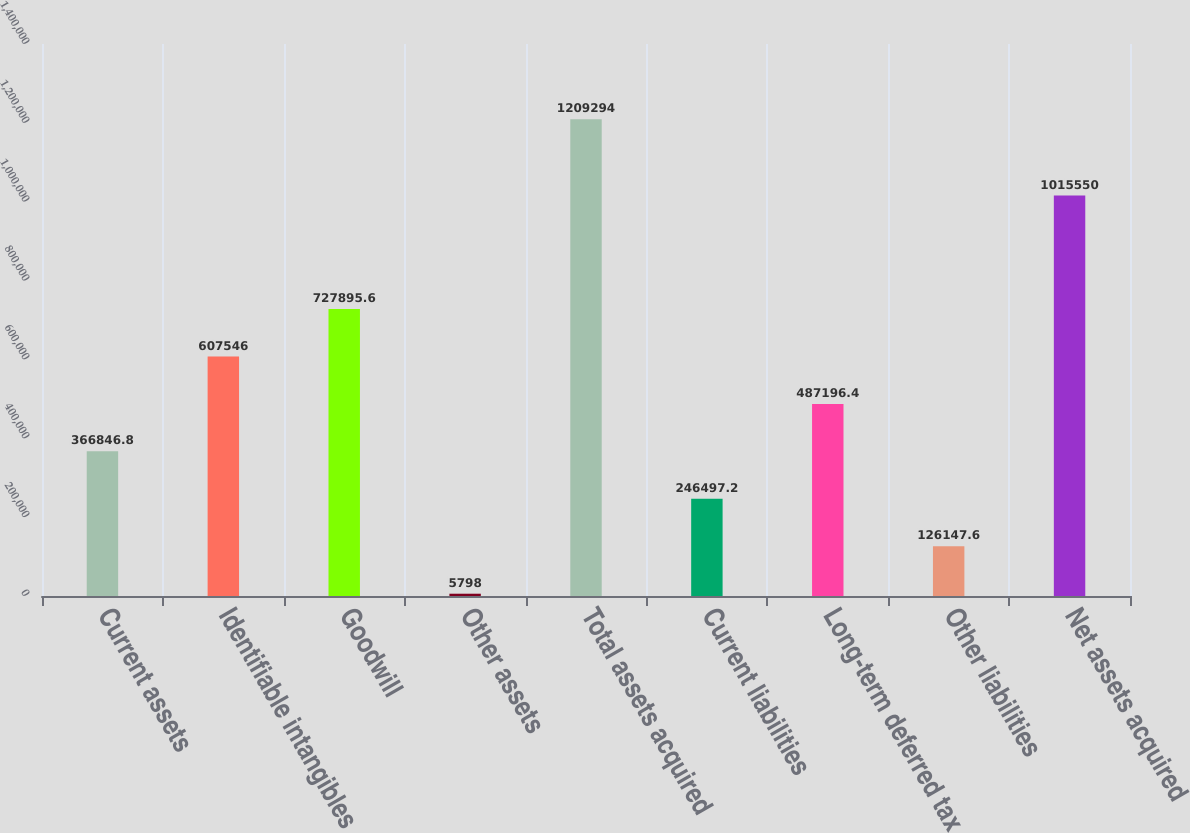Convert chart to OTSL. <chart><loc_0><loc_0><loc_500><loc_500><bar_chart><fcel>Current assets<fcel>Identifiable intangibles<fcel>Goodwill<fcel>Other assets<fcel>Total assets acquired<fcel>Current liabilities<fcel>Long-term deferred tax<fcel>Other liabilities<fcel>Net assets acquired<nl><fcel>366847<fcel>607546<fcel>727896<fcel>5798<fcel>1.20929e+06<fcel>246497<fcel>487196<fcel>126148<fcel>1.01555e+06<nl></chart> 